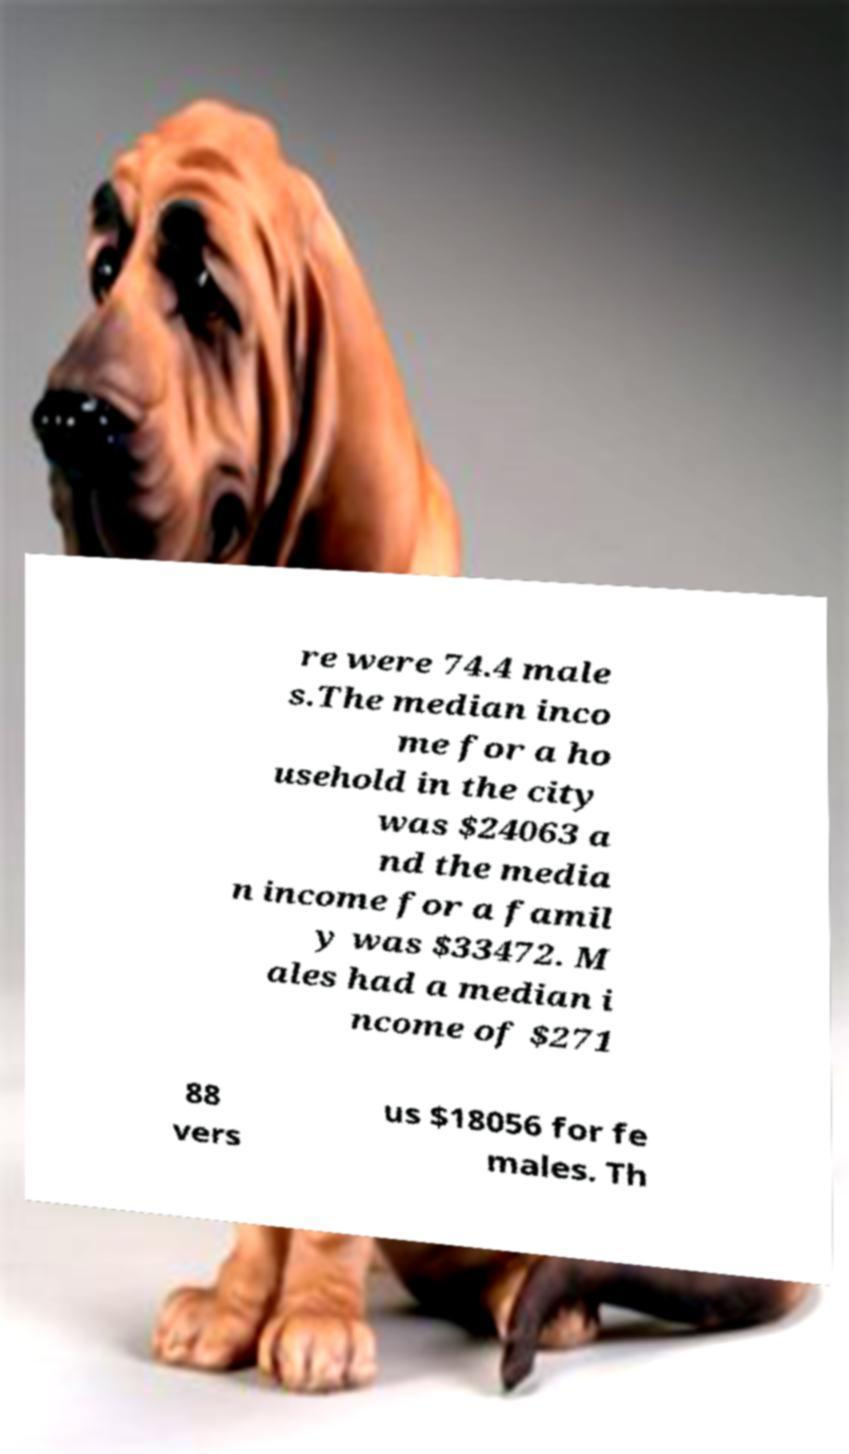There's text embedded in this image that I need extracted. Can you transcribe it verbatim? re were 74.4 male s.The median inco me for a ho usehold in the city was $24063 a nd the media n income for a famil y was $33472. M ales had a median i ncome of $271 88 vers us $18056 for fe males. Th 